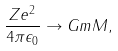<formula> <loc_0><loc_0><loc_500><loc_500>\frac { Z e ^ { 2 } } { 4 \pi \epsilon _ { 0 } } \rightarrow G m M ,</formula> 